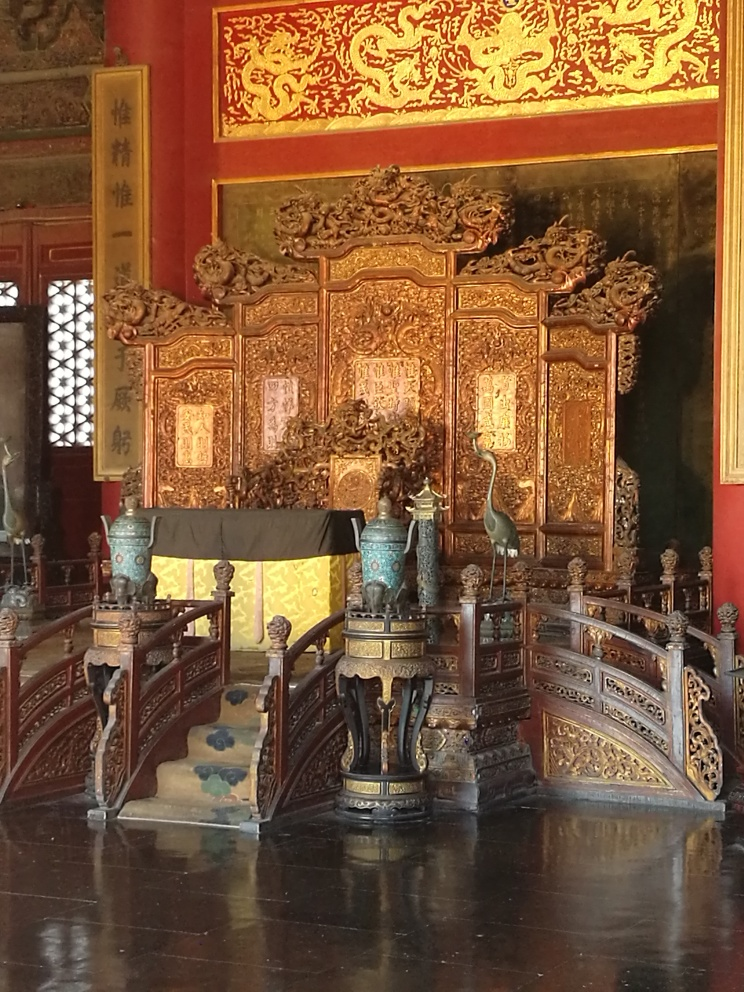What materials are used in the objects surrounding the throne? The throne itself seems to be made from lacquered wood, gilded with gold, and inlaid with possibly jade or ivory. The vases on the stands are likely bronze, with a patina indicative of age, and the stands themselves exhibit a high level of craftsmanship, possibly also wood with metal accents. Could these objects be considered valuable? Indeed, objects like these are often of significant historical and cultural value. Their craftsmanship, materials, and association with royal or ceremonial use in ancient times could make them highly prized items in collections and could command considerable interest in an auction setting. 